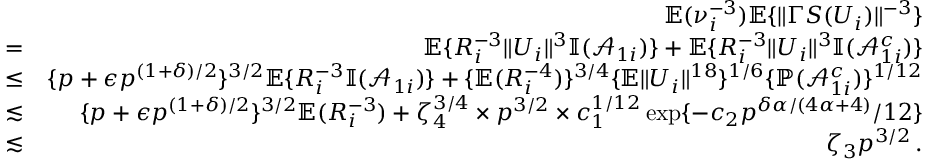Convert formula to latex. <formula><loc_0><loc_0><loc_500><loc_500>\begin{array} { r l r } & { { \mathbb { E } } ( \nu _ { i } ^ { - 3 } ) { \mathbb { E } } \{ \| \Gamma S ( U _ { i } ) \| ^ { - 3 } \} } \\ & { = } & { { \mathbb { E } } \{ R _ { i } ^ { - 3 } \| U _ { i } \| ^ { 3 } { \mathbb { I } } ( \mathcal { A } _ { 1 i } ) \} + { \mathbb { E } } \{ R _ { i } ^ { - 3 } \| U _ { i } \| ^ { 3 } { \mathbb { I } } ( \mathcal { A } _ { 1 i } ^ { c } ) \} } \\ & { \leq } & { \{ p + \epsilon p ^ { ( 1 + \delta ) / 2 } \} ^ { 3 / 2 } { \mathbb { E } } \{ R _ { i } ^ { - 3 } { \mathbb { I } } ( \mathcal { A } _ { 1 i } ) \} + \{ { \mathbb { E } } ( R _ { i } ^ { - 4 } ) \} ^ { 3 / 4 } \{ { \mathbb { E } } \| U _ { i } \| ^ { 1 8 } \} ^ { 1 / 6 } \{ { \mathbb { P } } ( \mathcal { A } _ { 1 i } ^ { c } ) \} ^ { 1 / 1 2 } } \\ & { \lesssim } & { \{ p + \epsilon p ^ { ( 1 + \delta ) / 2 } \} ^ { 3 / 2 } { \mathbb { E } } ( R _ { i } ^ { - 3 } ) + \zeta _ { 4 } ^ { 3 / 4 } \times p ^ { 3 / 2 } \times c _ { 1 } ^ { 1 / 1 2 } \exp \{ - c _ { 2 } p ^ { \delta \alpha / ( 4 \alpha + 4 ) } / 1 2 \} } \\ & { \lesssim } & { \zeta _ { 3 } p ^ { 3 / 2 } \, . } \end{array}</formula> 